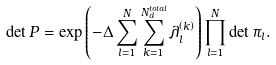Convert formula to latex. <formula><loc_0><loc_0><loc_500><loc_500>\det P = \exp \left ( - \Delta \sum _ { l = 1 } ^ { N } \sum _ { k = 1 } ^ { N _ { d } ^ { t o t a l } } \lambda _ { l } ^ { \left ( k \right ) } \right ) \prod _ { l = 1 } ^ { N } \det \pi _ { l } .</formula> 